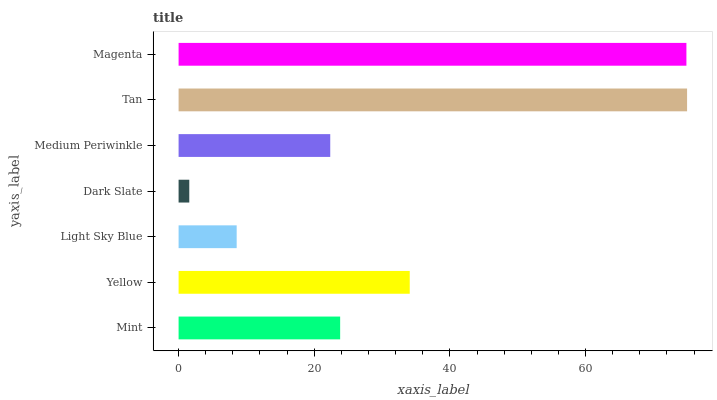Is Dark Slate the minimum?
Answer yes or no. Yes. Is Tan the maximum?
Answer yes or no. Yes. Is Yellow the minimum?
Answer yes or no. No. Is Yellow the maximum?
Answer yes or no. No. Is Yellow greater than Mint?
Answer yes or no. Yes. Is Mint less than Yellow?
Answer yes or no. Yes. Is Mint greater than Yellow?
Answer yes or no. No. Is Yellow less than Mint?
Answer yes or no. No. Is Mint the high median?
Answer yes or no. Yes. Is Mint the low median?
Answer yes or no. Yes. Is Yellow the high median?
Answer yes or no. No. Is Yellow the low median?
Answer yes or no. No. 